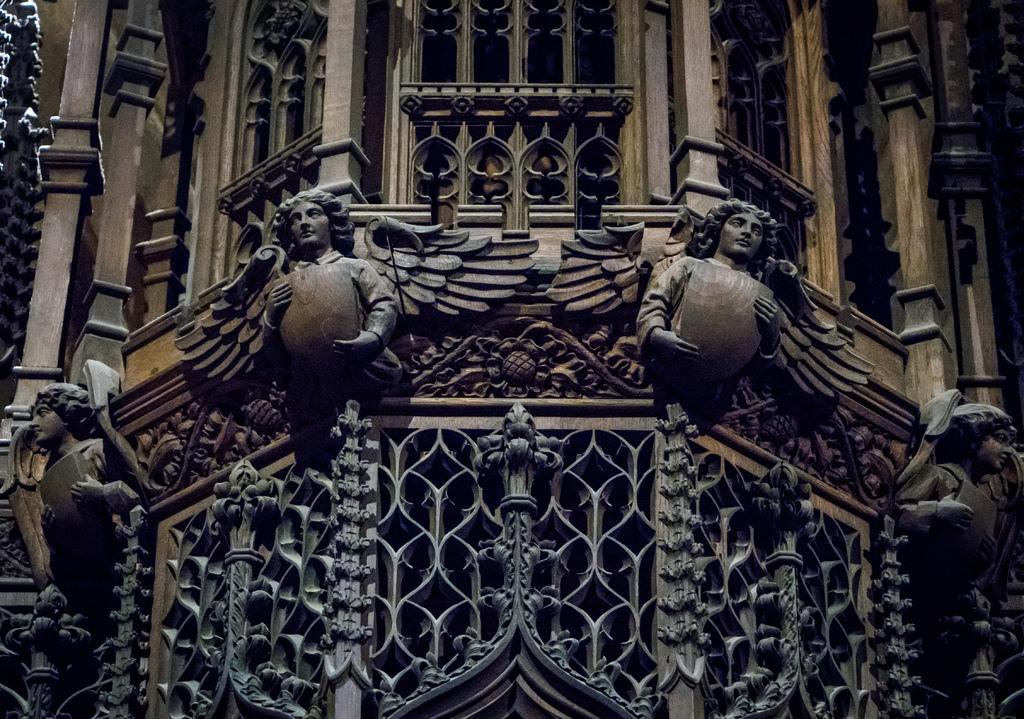Could you give a brief overview of what you see in this image? In this image there is a building in the middle and there are sculptures to its wall. At the bottom there are some design grills. 